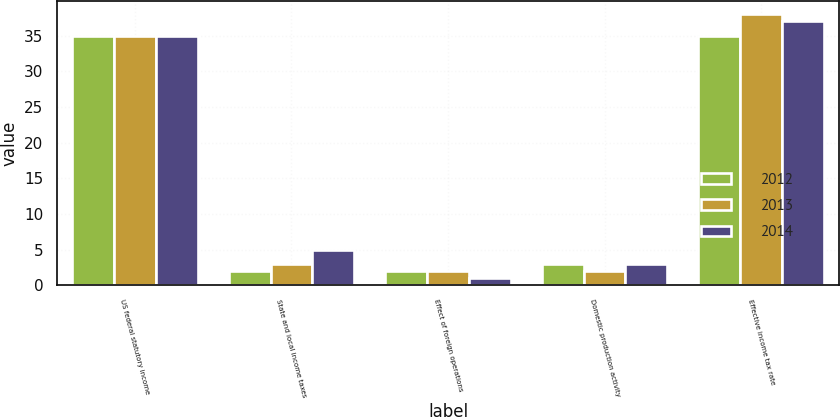<chart> <loc_0><loc_0><loc_500><loc_500><stacked_bar_chart><ecel><fcel>US federal statutory income<fcel>State and local income taxes<fcel>Effect of foreign operations<fcel>Domestic production activity<fcel>Effective income tax rate<nl><fcel>2012<fcel>35<fcel>2<fcel>2<fcel>3<fcel>35<nl><fcel>2013<fcel>35<fcel>3<fcel>2<fcel>2<fcel>38<nl><fcel>2014<fcel>35<fcel>5<fcel>1<fcel>3<fcel>37<nl></chart> 